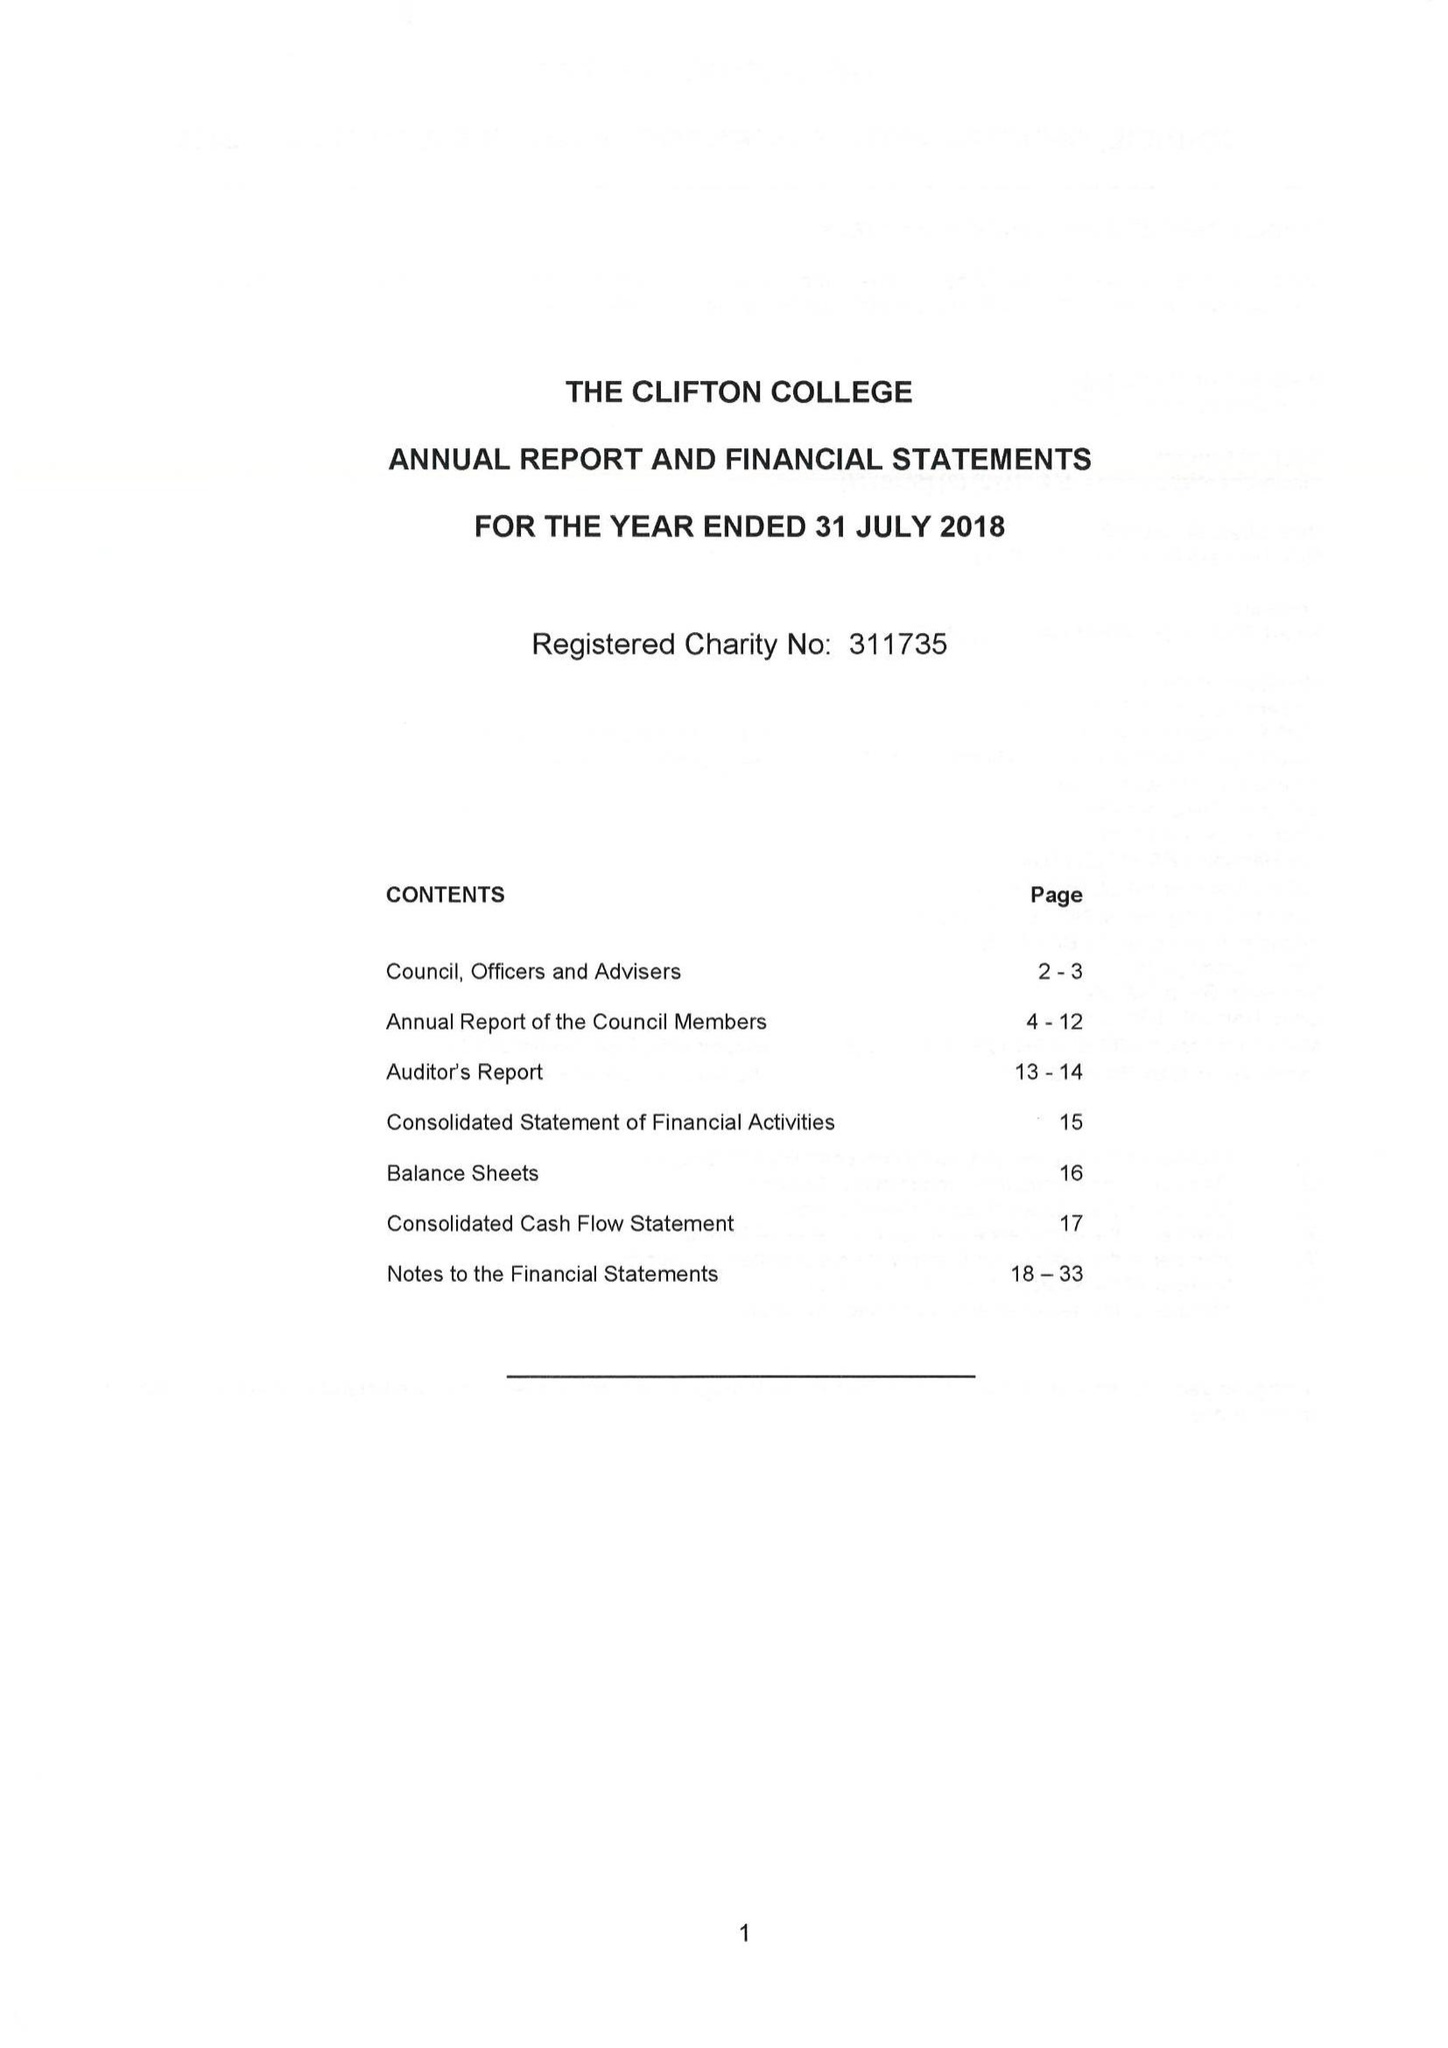What is the value for the spending_annually_in_british_pounds?
Answer the question using a single word or phrase. 28396526.00 